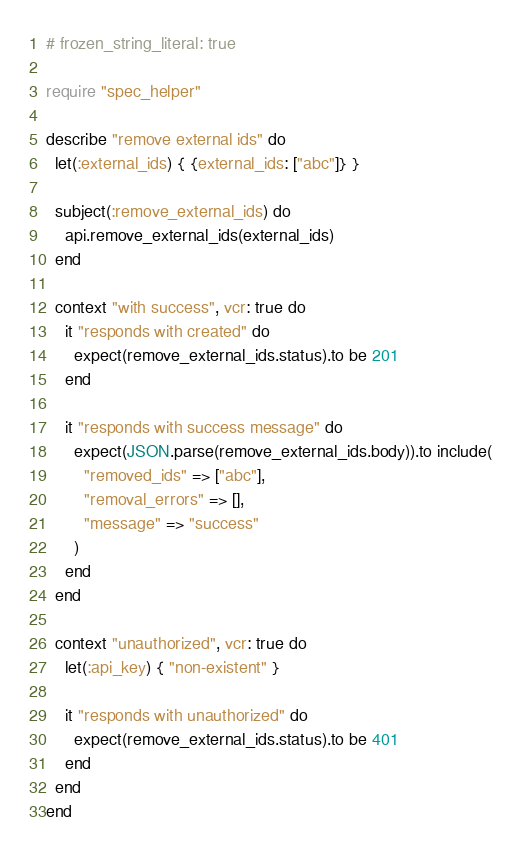<code> <loc_0><loc_0><loc_500><loc_500><_Ruby_># frozen_string_literal: true

require "spec_helper"

describe "remove external ids" do
  let(:external_ids) { {external_ids: ["abc"]} }

  subject(:remove_external_ids) do
    api.remove_external_ids(external_ids)
  end

  context "with success", vcr: true do
    it "responds with created" do
      expect(remove_external_ids.status).to be 201
    end

    it "responds with success message" do
      expect(JSON.parse(remove_external_ids.body)).to include(
        "removed_ids" => ["abc"],
        "removal_errors" => [],
        "message" => "success"
      )
    end
  end

  context "unauthorized", vcr: true do
    let(:api_key) { "non-existent" }

    it "responds with unauthorized" do
      expect(remove_external_ids.status).to be 401
    end
  end
end
</code> 